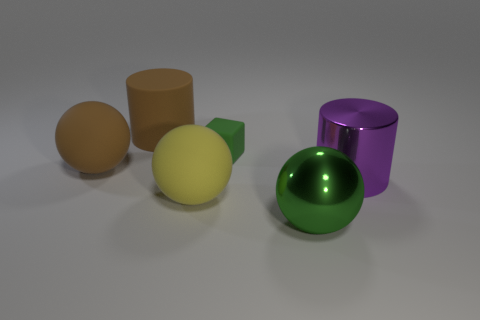Subtract all big green metallic spheres. How many spheres are left? 2 Add 1 small green matte cubes. How many objects exist? 7 Subtract all brown balls. How many balls are left? 2 Subtract all cylinders. How many objects are left? 4 Subtract all red cubes. Subtract all yellow cylinders. How many cubes are left? 1 Subtract all tiny brown things. Subtract all large brown rubber spheres. How many objects are left? 5 Add 5 brown rubber objects. How many brown rubber objects are left? 7 Add 5 yellow matte cubes. How many yellow matte cubes exist? 5 Subtract 0 blue blocks. How many objects are left? 6 